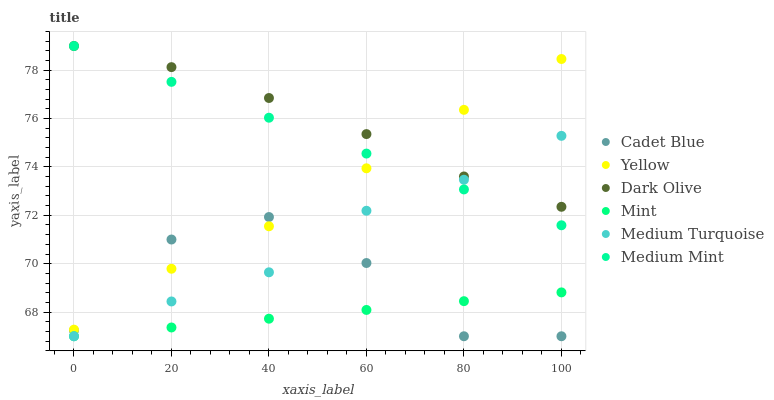Does Mint have the minimum area under the curve?
Answer yes or no. Yes. Does Dark Olive have the maximum area under the curve?
Answer yes or no. Yes. Does Cadet Blue have the minimum area under the curve?
Answer yes or no. No. Does Cadet Blue have the maximum area under the curve?
Answer yes or no. No. Is Mint the smoothest?
Answer yes or no. Yes. Is Cadet Blue the roughest?
Answer yes or no. Yes. Is Dark Olive the smoothest?
Answer yes or no. No. Is Dark Olive the roughest?
Answer yes or no. No. Does Cadet Blue have the lowest value?
Answer yes or no. Yes. Does Dark Olive have the lowest value?
Answer yes or no. No. Does Dark Olive have the highest value?
Answer yes or no. Yes. Does Cadet Blue have the highest value?
Answer yes or no. No. Is Cadet Blue less than Dark Olive?
Answer yes or no. Yes. Is Medium Mint greater than Mint?
Answer yes or no. Yes. Does Dark Olive intersect Medium Turquoise?
Answer yes or no. Yes. Is Dark Olive less than Medium Turquoise?
Answer yes or no. No. Is Dark Olive greater than Medium Turquoise?
Answer yes or no. No. Does Cadet Blue intersect Dark Olive?
Answer yes or no. No. 